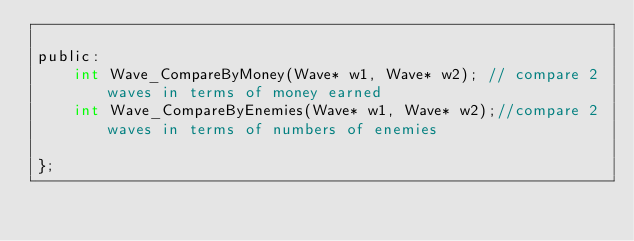<code> <loc_0><loc_0><loc_500><loc_500><_C_>
public:
	int Wave_CompareByMoney(Wave* w1, Wave* w2); // compare 2 waves in terms of money earned 
	int Wave_CompareByEnemies(Wave* w1, Wave* w2);//compare 2 waves in terms of numbers of enemies 

};
</code> 